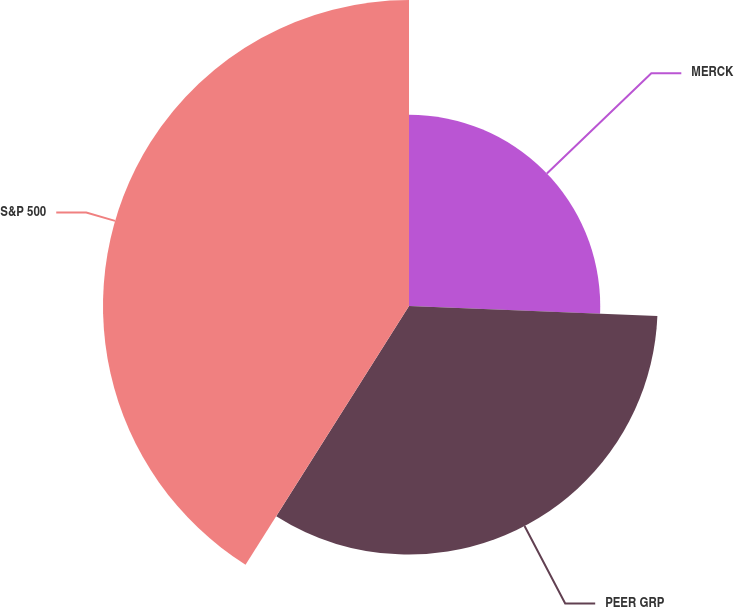Convert chart. <chart><loc_0><loc_0><loc_500><loc_500><pie_chart><fcel>MERCK<fcel>PEER GRP<fcel>S&P 500<nl><fcel>25.64%<fcel>33.33%<fcel>41.03%<nl></chart> 